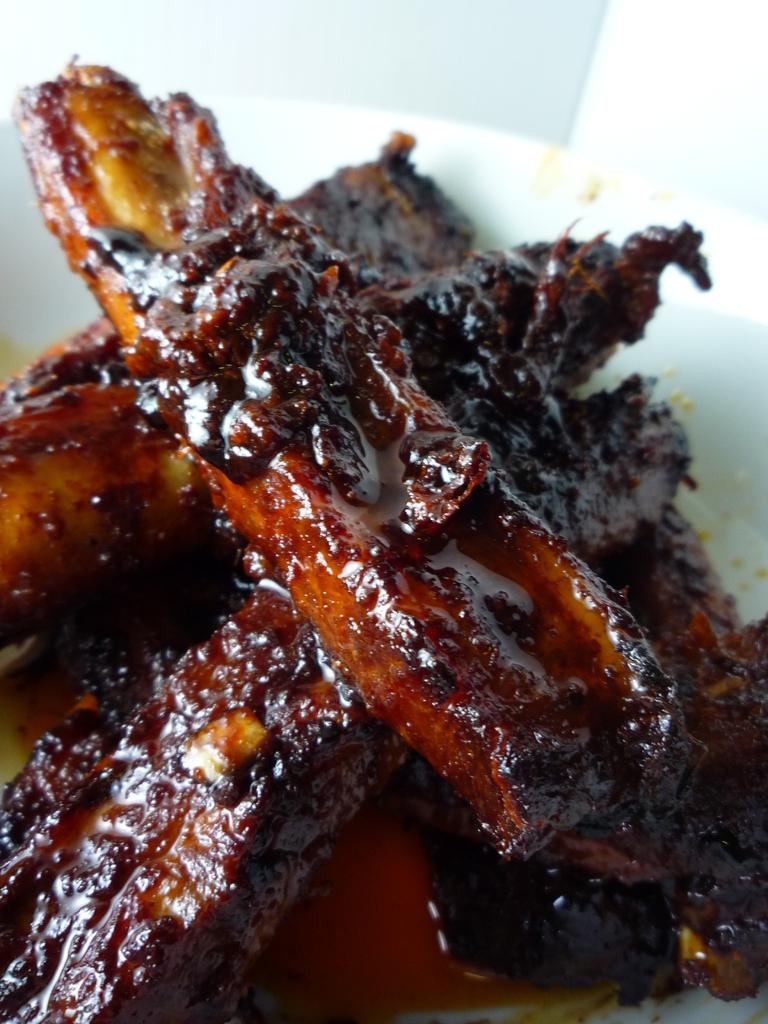What type of objects can be seen in the image? There are food items in the image. How are the food items arranged or presented? The food items are in a white color plate. What type of stocking is visible in the image? There is no stocking present in the image. Can you tell me the account balance of the person in the image? There is no person or account balance mentioned in the image. 